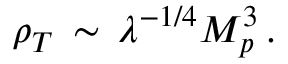Convert formula to latex. <formula><loc_0><loc_0><loc_500><loc_500>\rho _ { T } \, \sim \, \lambda ^ { - 1 / 4 } M _ { p } ^ { 3 } \, .</formula> 